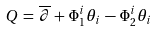Convert formula to latex. <formula><loc_0><loc_0><loc_500><loc_500>Q \, = \, \overline { \partial } \, + \, \Phi _ { 1 } ^ { i } \theta _ { i } \, - \, \Phi _ { 2 } ^ { i } \theta _ { i }</formula> 